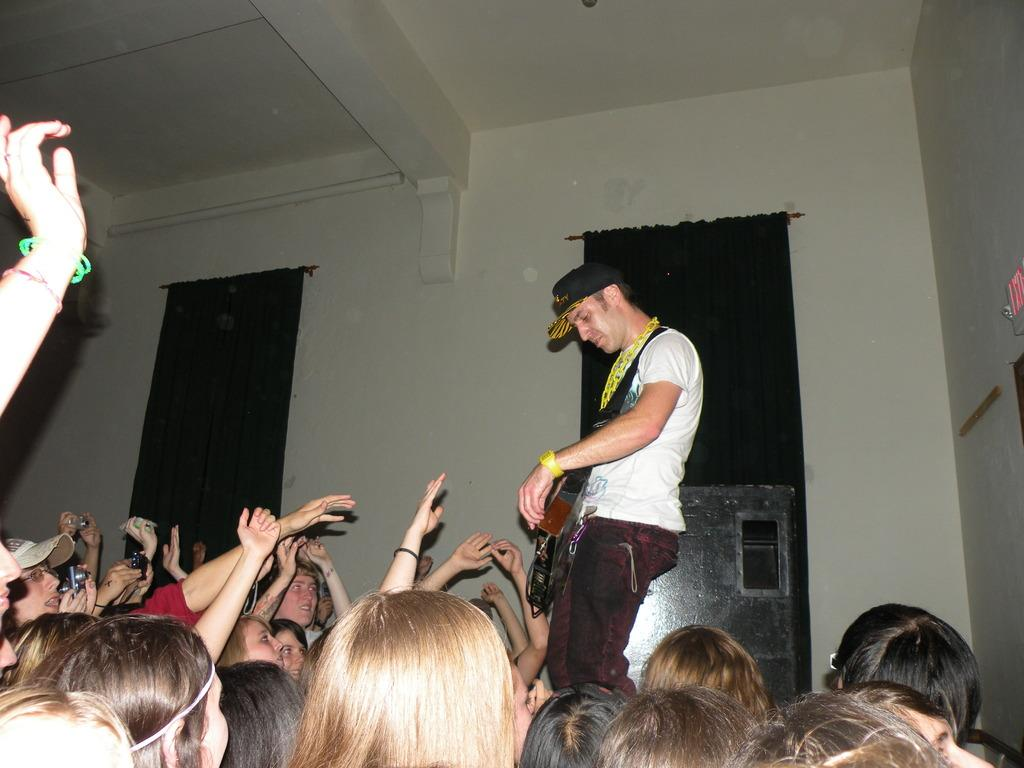How many people are in the image? There is a group of persons in the image. What are the persons doing in the image? One person is playing a musical instrument. What is located behind the persons in the image? There is a wall behind the persons. What type of window treatment is associated with the wall? There are curtains associated with the wall. What part of the building can be seen at the top of the image? The roof is visible at the top of the image. Can you see a ladybug crawling on the musical instrument in the image? There is no ladybug present in the image. What type of bean is being cooked on the stove in the image? There is no stove or bean present in the image. 